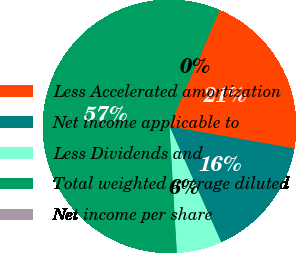Convert chart to OTSL. <chart><loc_0><loc_0><loc_500><loc_500><pie_chart><fcel>Less Accelerated amortization<fcel>Net income applicable to<fcel>Less Dividends and<fcel>Total weighted average diluted<fcel>Net income per share<nl><fcel>21.28%<fcel>15.54%<fcel>5.75%<fcel>57.42%<fcel>0.0%<nl></chart> 